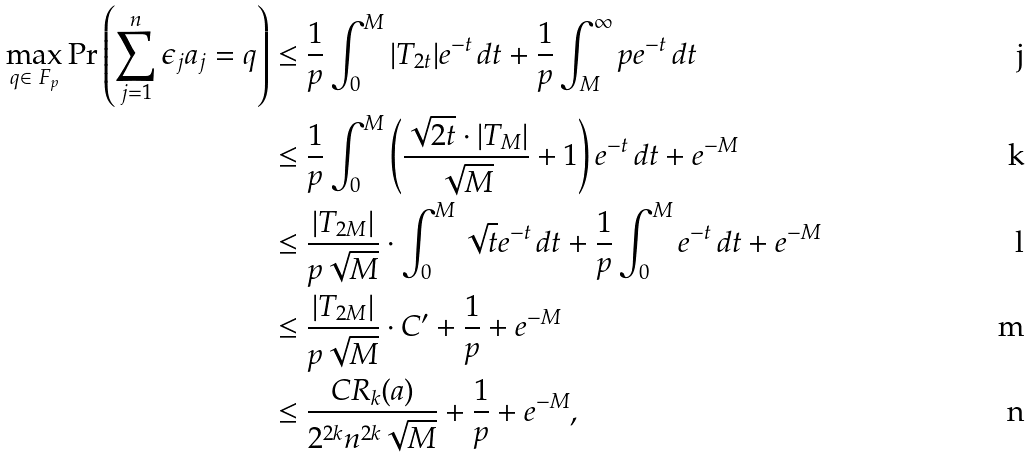<formula> <loc_0><loc_0><loc_500><loc_500>\max _ { q \in \ F _ { p } } \Pr \left ( \sum _ { j = 1 } ^ { n } \epsilon _ { j } a _ { j } = q \right ) & \leq \frac { 1 } { p } \int _ { 0 } ^ { M } | T _ { 2 t } | e ^ { - t } \, d t + \frac { 1 } { p } \int _ { M } ^ { \infty } p e ^ { - t } \, d t \\ & \leq \frac { 1 } { p } \int _ { 0 } ^ { M } \left ( \frac { \sqrt { 2 t } \cdot | T _ { M } | } { \sqrt { M } } + 1 \right ) e ^ { - t } \, d t + e ^ { - M } \\ & \leq \frac { | T _ { 2 M } | } { p \sqrt { M } } \cdot \int _ { 0 } ^ { M } \sqrt { t } e ^ { - t } \, d t + \frac { 1 } { p } \int _ { 0 } ^ { M } e ^ { - t } \, d t + e ^ { - M } \\ & \leq \frac { | T _ { 2 M } | } { p \sqrt { M } } \cdot C ^ { \prime } + \frac { 1 } { p } + e ^ { - M } \\ & \leq \frac { C R _ { k } ( a ) } { 2 ^ { 2 k } n ^ { 2 k } \sqrt { M } } + \frac { 1 } { p } + e ^ { - M } ,</formula> 